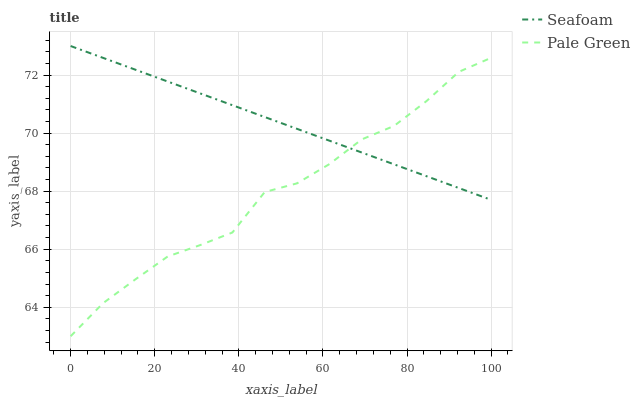Does Pale Green have the minimum area under the curve?
Answer yes or no. Yes. Does Seafoam have the maximum area under the curve?
Answer yes or no. Yes. Does Seafoam have the minimum area under the curve?
Answer yes or no. No. Is Seafoam the smoothest?
Answer yes or no. Yes. Is Pale Green the roughest?
Answer yes or no. Yes. Is Seafoam the roughest?
Answer yes or no. No. Does Pale Green have the lowest value?
Answer yes or no. Yes. Does Seafoam have the lowest value?
Answer yes or no. No. Does Seafoam have the highest value?
Answer yes or no. Yes. Does Pale Green intersect Seafoam?
Answer yes or no. Yes. Is Pale Green less than Seafoam?
Answer yes or no. No. Is Pale Green greater than Seafoam?
Answer yes or no. No. 